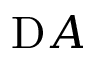Convert formula to latex. <formula><loc_0><loc_0><loc_500><loc_500>\mathrm A</formula> 